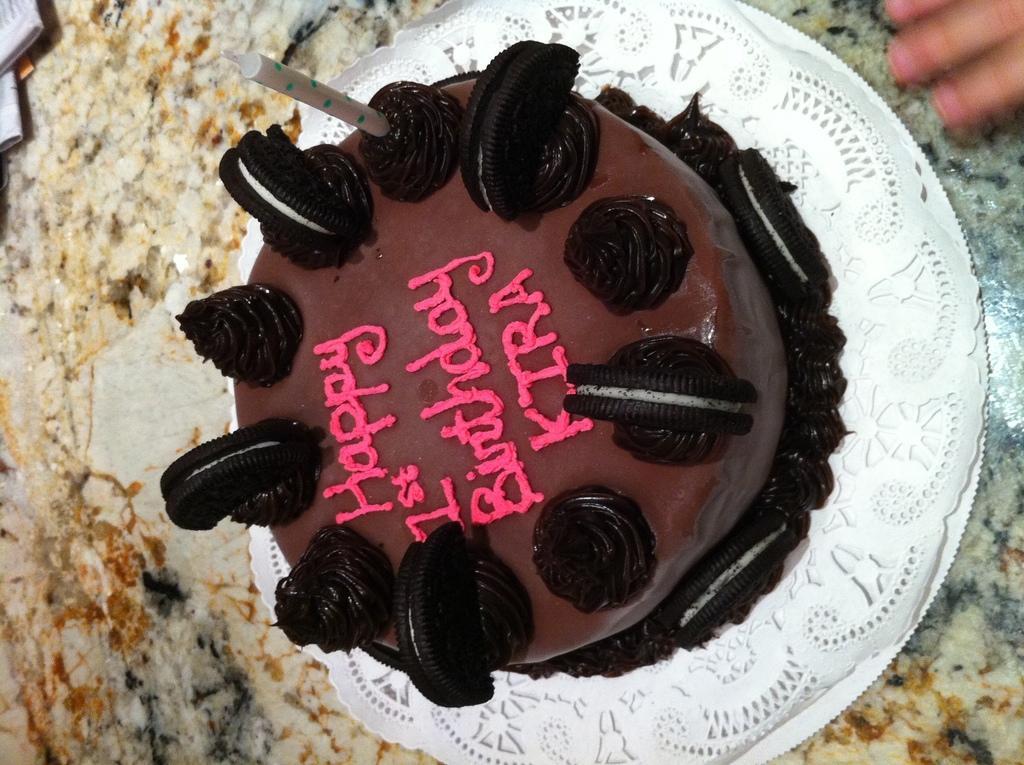Please provide a concise description of this image. In this image I can see a white colour cloth in the centre and on it I can see a black and brown colour cake. I can also see something is written on the cake. On the top right corner of this image I can see fingers of a person and on the the top left side I can see few white colour things. 